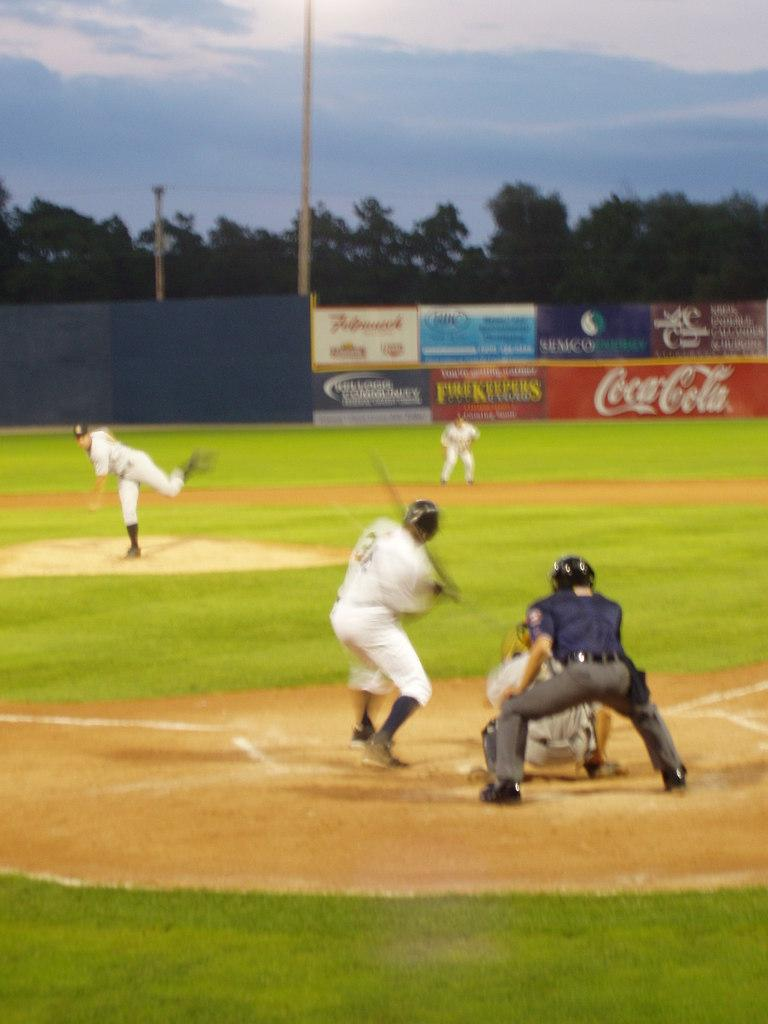<image>
Create a compact narrative representing the image presented. A baseball game is underway in a field that has a Coca-Cola sign. 